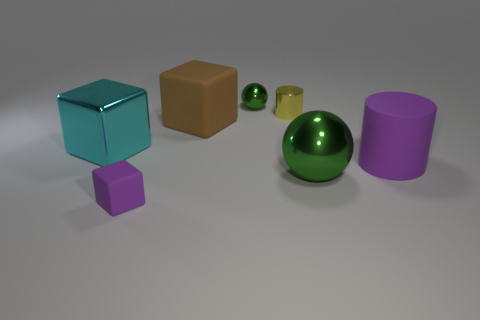There is a big object that is behind the large cylinder and on the right side of the large cyan block; what is its shape? The shape of the object situated behind the large cylinder and on the right side of the large cyan block is a cube. It features a distinct six-sided square geometry typical of a cube, with each side equal in length. 